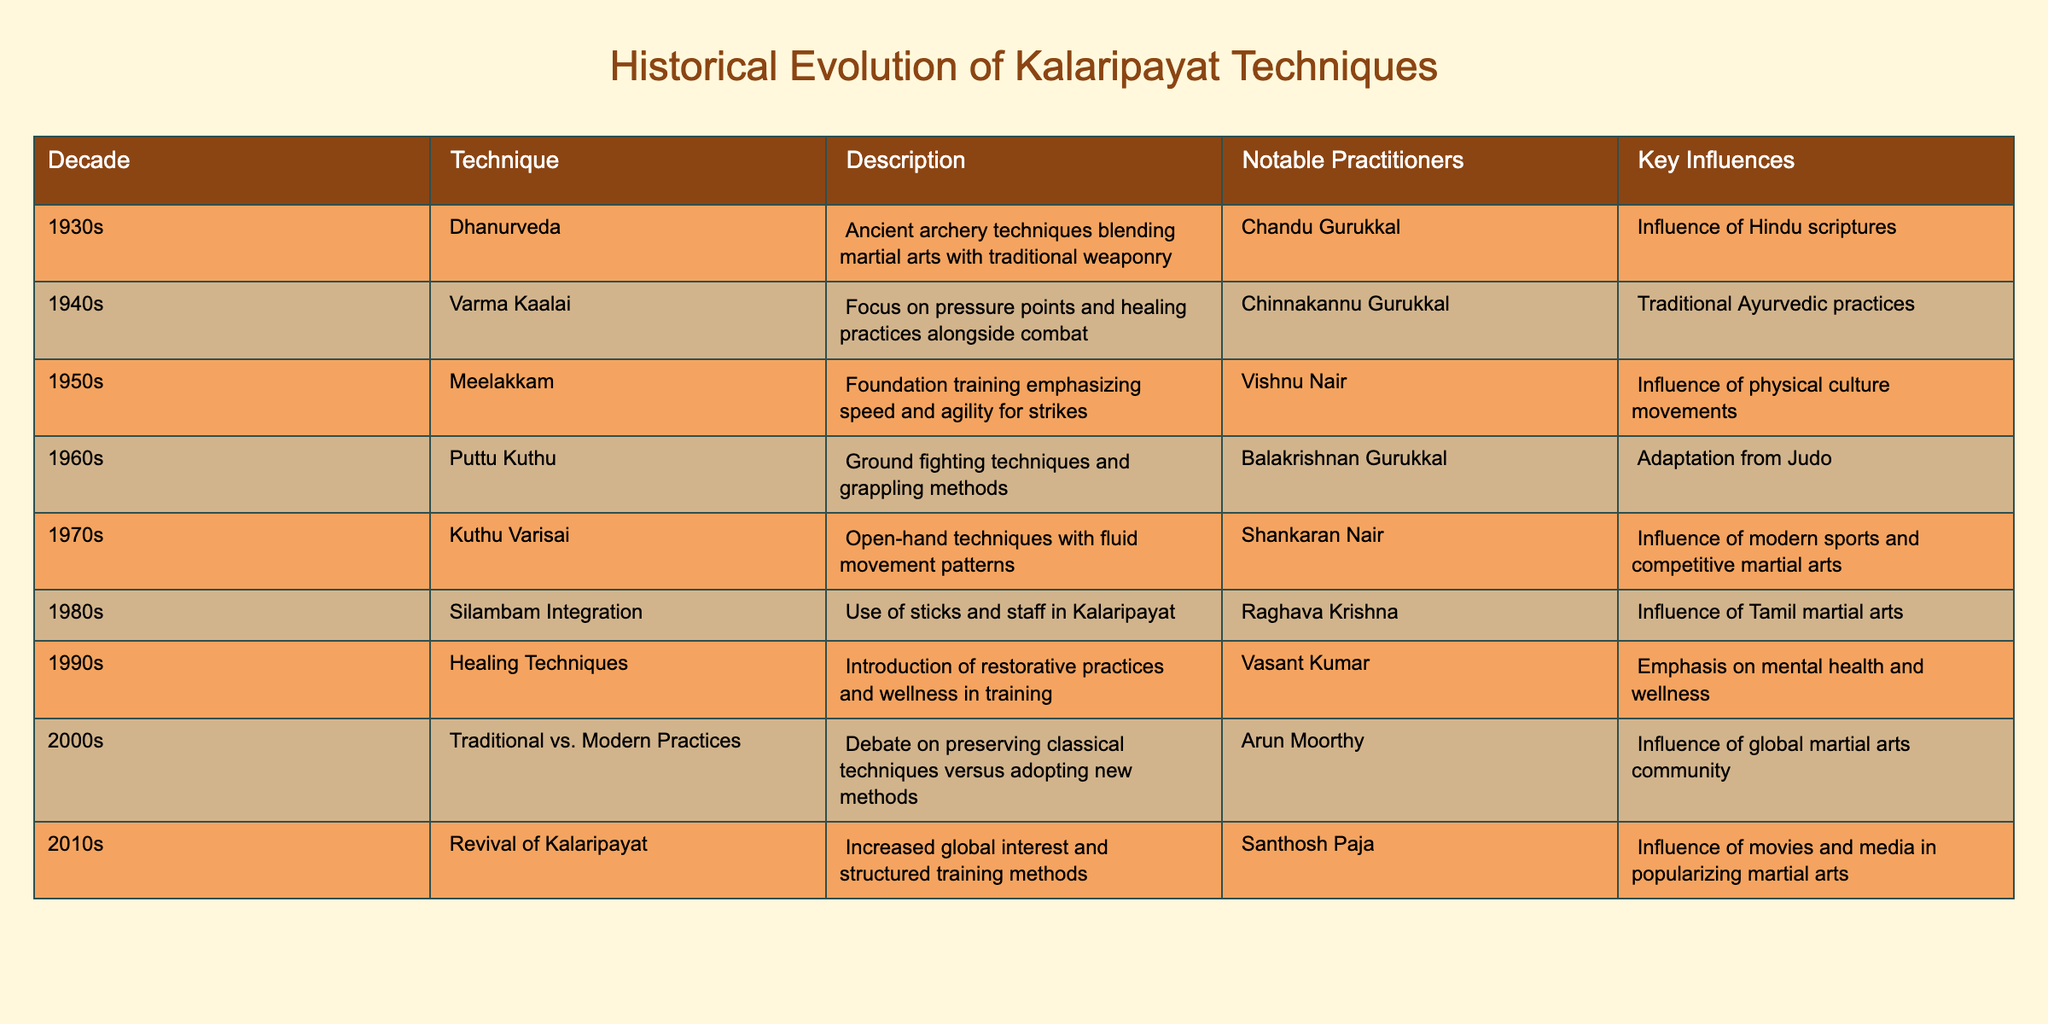What technique was focused on pressure points and healing practices? The table indicates that the technique from the 1940s was Varma Kaalai, which is described as focusing on pressure points and healing practices alongside combat.
Answer: Varma Kaalai Which decade introduced the use of sticks and staff in Kalaripayat? According to the table, the 1980s marked the integration of Silambam, which is the use of sticks and staff in Kalaripayat.
Answer: 1980s Did the 1960s technique Puttu Kuthu have an influence from Judo? The table explicitly mentions that the 1960s technique Puttu Kuthu was influenced by Judo. Therefore, the statement is true.
Answer: Yes What is the notable influence on healing techniques introduced in the 1990s? From the table, the notable influence on the healing techniques introduced in the 1990s was an emphasis on mental health and wellness.
Answer: Mental health and wellness Which technique emphasizes speed and agility for strikes and who is the notable practitioner from that era? The technique that emphasizes speed and agility for strikes is Meelakkam from the 1950s, and its notable practitioner is Vishnu Nair.
Answer: Meelakkam, Vishnu Nair What is the difference in training focus between the techniques of the 2000s and the 2010s? In the 2000s, the focus was on the debate over traditional versus modern practices, while in the 2010s, the emphasis shifted towards the revival of Kalaripayat and structured training methods. This shows a transition from debate to active revival efforts.
Answer: Traditional vs. Modern Practices vs. Revival How many techniques introduced between the 1930s and the 1950s focused primarily on combat? From the 1930s to the 1950s, there are three techniques mentioned in the table (Dhanurveda, Varma Kaalai, and Meelakkam) that focus primarily on combat.
Answer: Three techniques Was there a significant change in Kalaripayat practices during the 2010s in terms of global interest? Yes, the table indicates a significant increase in global interest in Kalaripayat during the 2010s, as it mentions structured training methods and influences from movies and media.
Answer: Yes 